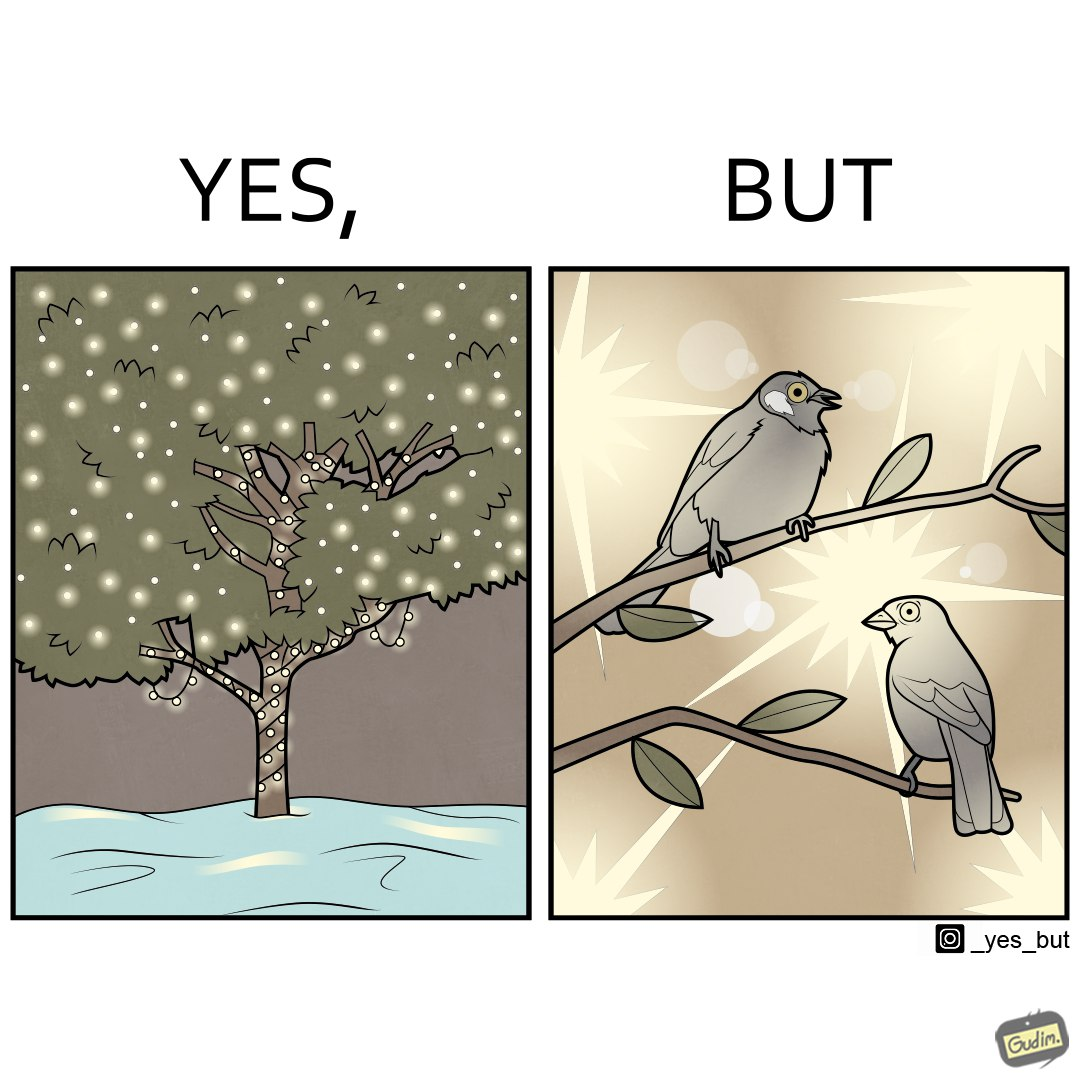Explain why this image is satirical. The images are ironic since they show how putting a lot of lights as decorations on trees make them beautiful to look at for us but cause trouble to the birds who actually live on trees for no good reason 